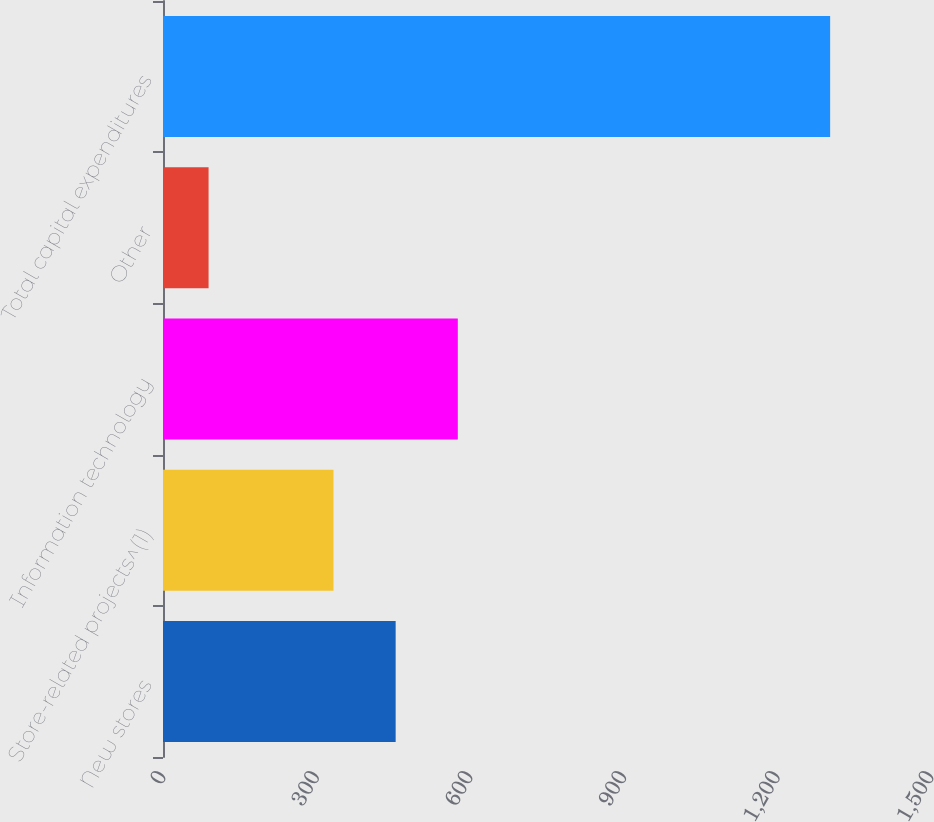Convert chart to OTSL. <chart><loc_0><loc_0><loc_500><loc_500><bar_chart><fcel>New stores<fcel>Store-related projects^(1)<fcel>Information technology<fcel>Other<fcel>Total capital expenditures<nl><fcel>454.4<fcel>333<fcel>575.8<fcel>89<fcel>1303<nl></chart> 